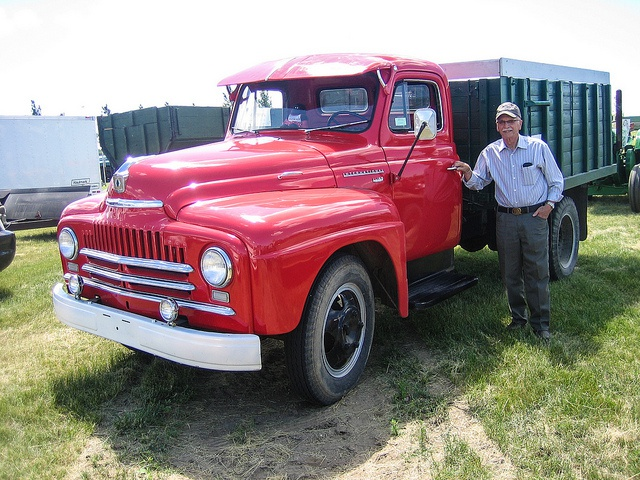Describe the objects in this image and their specific colors. I can see truck in white, black, brown, and lavender tones, people in white, black, darkgray, gray, and darkblue tones, and truck in white, gray, blue, and darkblue tones in this image. 